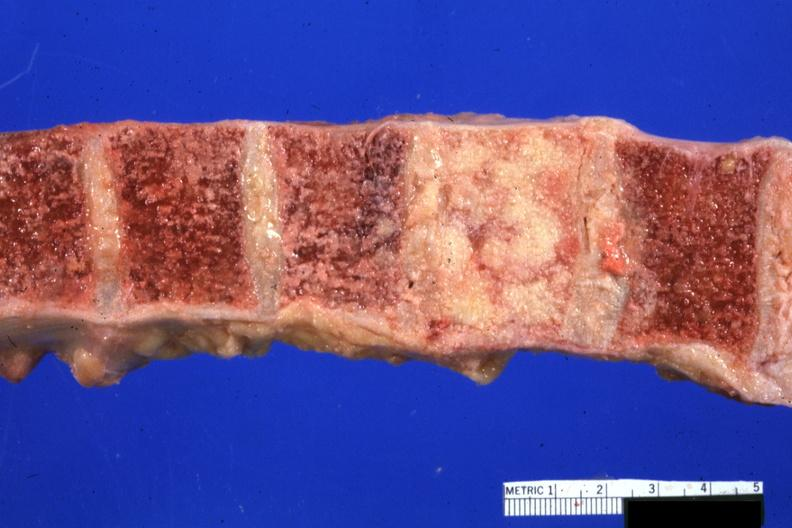how many cord does this image show vertebral bodies with one completely replaced by neoplasm excellent photo compression?
Answer the question using a single word or phrase. 68yowm 